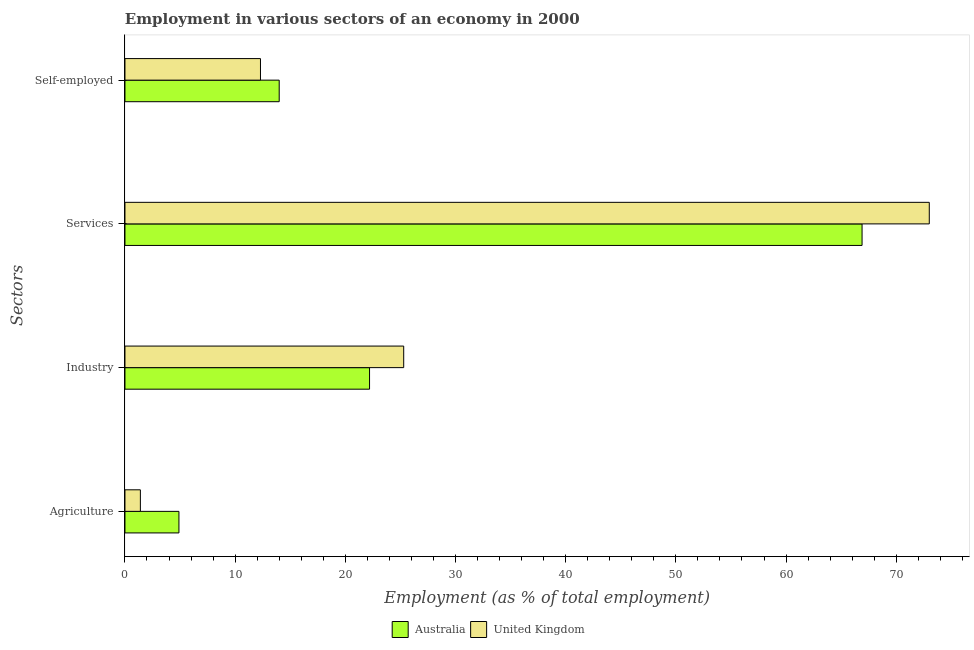How many different coloured bars are there?
Offer a terse response. 2. Are the number of bars per tick equal to the number of legend labels?
Your answer should be compact. Yes. Are the number of bars on each tick of the Y-axis equal?
Your response must be concise. Yes. How many bars are there on the 2nd tick from the bottom?
Offer a terse response. 2. What is the label of the 1st group of bars from the top?
Offer a terse response. Self-employed. What is the percentage of workers in industry in United Kingdom?
Offer a very short reply. 25.3. Across all countries, what is the maximum percentage of self employed workers?
Offer a very short reply. 14. Across all countries, what is the minimum percentage of workers in agriculture?
Keep it short and to the point. 1.4. In which country was the percentage of workers in industry maximum?
Offer a terse response. United Kingdom. In which country was the percentage of workers in industry minimum?
Your answer should be very brief. Australia. What is the total percentage of self employed workers in the graph?
Keep it short and to the point. 26.3. What is the difference between the percentage of workers in services in Australia and that in United Kingdom?
Your response must be concise. -6.1. What is the difference between the percentage of workers in services in Australia and the percentage of self employed workers in United Kingdom?
Ensure brevity in your answer.  54.6. What is the average percentage of self employed workers per country?
Offer a terse response. 13.15. What is the difference between the percentage of workers in services and percentage of workers in industry in Australia?
Offer a terse response. 44.7. What is the ratio of the percentage of workers in industry in United Kingdom to that in Australia?
Offer a terse response. 1.14. Is the difference between the percentage of self employed workers in Australia and United Kingdom greater than the difference between the percentage of workers in services in Australia and United Kingdom?
Make the answer very short. Yes. What is the difference between the highest and the second highest percentage of workers in services?
Offer a terse response. 6.1. What is the difference between the highest and the lowest percentage of workers in industry?
Keep it short and to the point. 3.1. In how many countries, is the percentage of workers in agriculture greater than the average percentage of workers in agriculture taken over all countries?
Provide a short and direct response. 1. Is the sum of the percentage of self employed workers in Australia and United Kingdom greater than the maximum percentage of workers in industry across all countries?
Give a very brief answer. Yes. Is it the case that in every country, the sum of the percentage of workers in agriculture and percentage of workers in services is greater than the sum of percentage of self employed workers and percentage of workers in industry?
Make the answer very short. No. Is it the case that in every country, the sum of the percentage of workers in agriculture and percentage of workers in industry is greater than the percentage of workers in services?
Your answer should be very brief. No. What is the difference between two consecutive major ticks on the X-axis?
Ensure brevity in your answer.  10. Are the values on the major ticks of X-axis written in scientific E-notation?
Offer a very short reply. No. How many legend labels are there?
Give a very brief answer. 2. How are the legend labels stacked?
Your answer should be very brief. Horizontal. What is the title of the graph?
Make the answer very short. Employment in various sectors of an economy in 2000. Does "Burundi" appear as one of the legend labels in the graph?
Ensure brevity in your answer.  No. What is the label or title of the X-axis?
Ensure brevity in your answer.  Employment (as % of total employment). What is the label or title of the Y-axis?
Your response must be concise. Sectors. What is the Employment (as % of total employment) in Australia in Agriculture?
Offer a very short reply. 4.9. What is the Employment (as % of total employment) in United Kingdom in Agriculture?
Provide a succinct answer. 1.4. What is the Employment (as % of total employment) of Australia in Industry?
Ensure brevity in your answer.  22.2. What is the Employment (as % of total employment) of United Kingdom in Industry?
Your answer should be very brief. 25.3. What is the Employment (as % of total employment) in Australia in Services?
Offer a terse response. 66.9. What is the Employment (as % of total employment) of United Kingdom in Self-employed?
Make the answer very short. 12.3. Across all Sectors, what is the maximum Employment (as % of total employment) in Australia?
Offer a very short reply. 66.9. Across all Sectors, what is the maximum Employment (as % of total employment) of United Kingdom?
Offer a terse response. 73. Across all Sectors, what is the minimum Employment (as % of total employment) of Australia?
Give a very brief answer. 4.9. Across all Sectors, what is the minimum Employment (as % of total employment) in United Kingdom?
Ensure brevity in your answer.  1.4. What is the total Employment (as % of total employment) in Australia in the graph?
Offer a very short reply. 108. What is the total Employment (as % of total employment) in United Kingdom in the graph?
Your answer should be very brief. 112. What is the difference between the Employment (as % of total employment) of Australia in Agriculture and that in Industry?
Offer a terse response. -17.3. What is the difference between the Employment (as % of total employment) of United Kingdom in Agriculture and that in Industry?
Make the answer very short. -23.9. What is the difference between the Employment (as % of total employment) in Australia in Agriculture and that in Services?
Offer a terse response. -62. What is the difference between the Employment (as % of total employment) of United Kingdom in Agriculture and that in Services?
Ensure brevity in your answer.  -71.6. What is the difference between the Employment (as % of total employment) in United Kingdom in Agriculture and that in Self-employed?
Give a very brief answer. -10.9. What is the difference between the Employment (as % of total employment) of Australia in Industry and that in Services?
Your response must be concise. -44.7. What is the difference between the Employment (as % of total employment) of United Kingdom in Industry and that in Services?
Your response must be concise. -47.7. What is the difference between the Employment (as % of total employment) in Australia in Services and that in Self-employed?
Provide a succinct answer. 52.9. What is the difference between the Employment (as % of total employment) of United Kingdom in Services and that in Self-employed?
Offer a terse response. 60.7. What is the difference between the Employment (as % of total employment) in Australia in Agriculture and the Employment (as % of total employment) in United Kingdom in Industry?
Your response must be concise. -20.4. What is the difference between the Employment (as % of total employment) in Australia in Agriculture and the Employment (as % of total employment) in United Kingdom in Services?
Your answer should be compact. -68.1. What is the difference between the Employment (as % of total employment) of Australia in Industry and the Employment (as % of total employment) of United Kingdom in Services?
Offer a terse response. -50.8. What is the difference between the Employment (as % of total employment) of Australia in Industry and the Employment (as % of total employment) of United Kingdom in Self-employed?
Your answer should be very brief. 9.9. What is the difference between the Employment (as % of total employment) of Australia in Services and the Employment (as % of total employment) of United Kingdom in Self-employed?
Make the answer very short. 54.6. What is the average Employment (as % of total employment) in United Kingdom per Sectors?
Provide a short and direct response. 28. What is the ratio of the Employment (as % of total employment) of Australia in Agriculture to that in Industry?
Offer a very short reply. 0.22. What is the ratio of the Employment (as % of total employment) in United Kingdom in Agriculture to that in Industry?
Your answer should be compact. 0.06. What is the ratio of the Employment (as % of total employment) of Australia in Agriculture to that in Services?
Provide a succinct answer. 0.07. What is the ratio of the Employment (as % of total employment) of United Kingdom in Agriculture to that in Services?
Provide a succinct answer. 0.02. What is the ratio of the Employment (as % of total employment) of Australia in Agriculture to that in Self-employed?
Provide a succinct answer. 0.35. What is the ratio of the Employment (as % of total employment) in United Kingdom in Agriculture to that in Self-employed?
Keep it short and to the point. 0.11. What is the ratio of the Employment (as % of total employment) of Australia in Industry to that in Services?
Your answer should be compact. 0.33. What is the ratio of the Employment (as % of total employment) in United Kingdom in Industry to that in Services?
Offer a very short reply. 0.35. What is the ratio of the Employment (as % of total employment) of Australia in Industry to that in Self-employed?
Offer a very short reply. 1.59. What is the ratio of the Employment (as % of total employment) in United Kingdom in Industry to that in Self-employed?
Your answer should be compact. 2.06. What is the ratio of the Employment (as % of total employment) of Australia in Services to that in Self-employed?
Provide a succinct answer. 4.78. What is the ratio of the Employment (as % of total employment) in United Kingdom in Services to that in Self-employed?
Provide a short and direct response. 5.93. What is the difference between the highest and the second highest Employment (as % of total employment) in Australia?
Ensure brevity in your answer.  44.7. What is the difference between the highest and the second highest Employment (as % of total employment) in United Kingdom?
Your response must be concise. 47.7. What is the difference between the highest and the lowest Employment (as % of total employment) of Australia?
Give a very brief answer. 62. What is the difference between the highest and the lowest Employment (as % of total employment) of United Kingdom?
Your response must be concise. 71.6. 